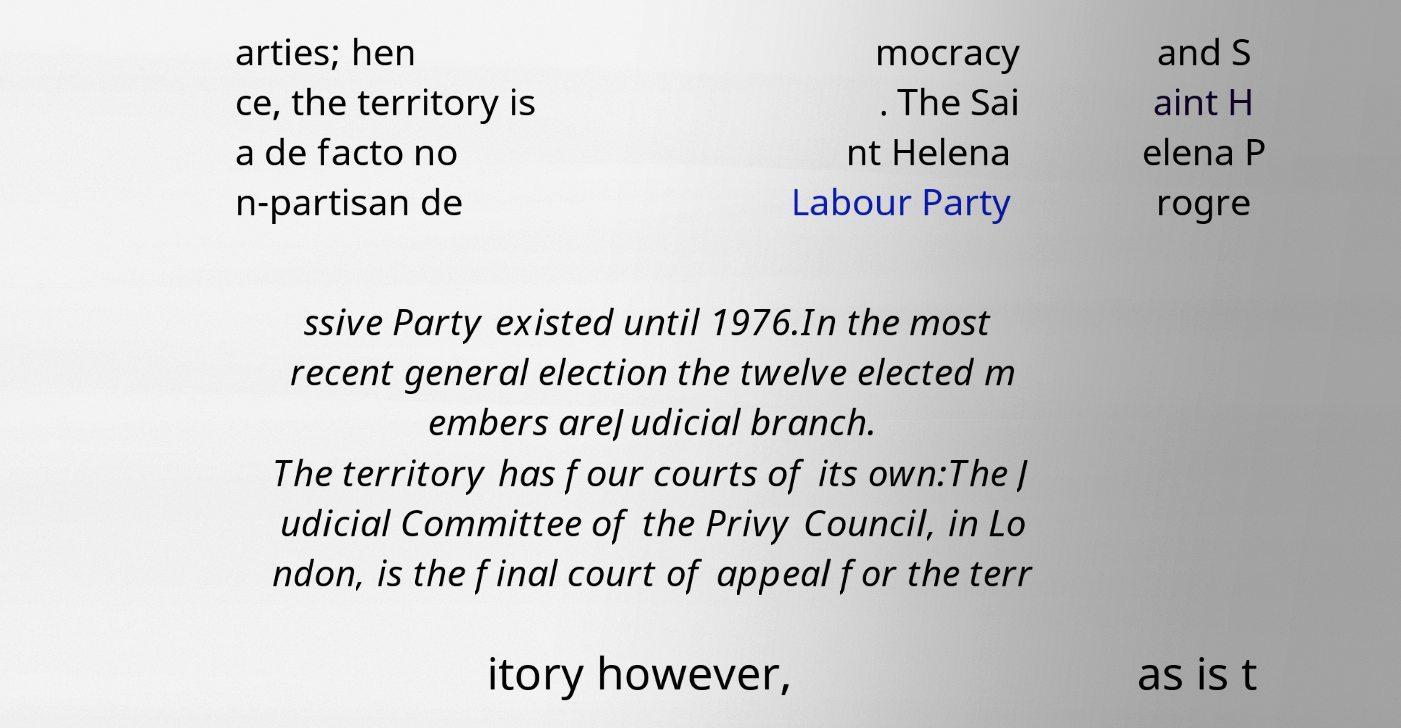Could you assist in decoding the text presented in this image and type it out clearly? arties; hen ce, the territory is a de facto no n-partisan de mocracy . The Sai nt Helena Labour Party and S aint H elena P rogre ssive Party existed until 1976.In the most recent general election the twelve elected m embers areJudicial branch. The territory has four courts of its own:The J udicial Committee of the Privy Council, in Lo ndon, is the final court of appeal for the terr itory however, as is t 